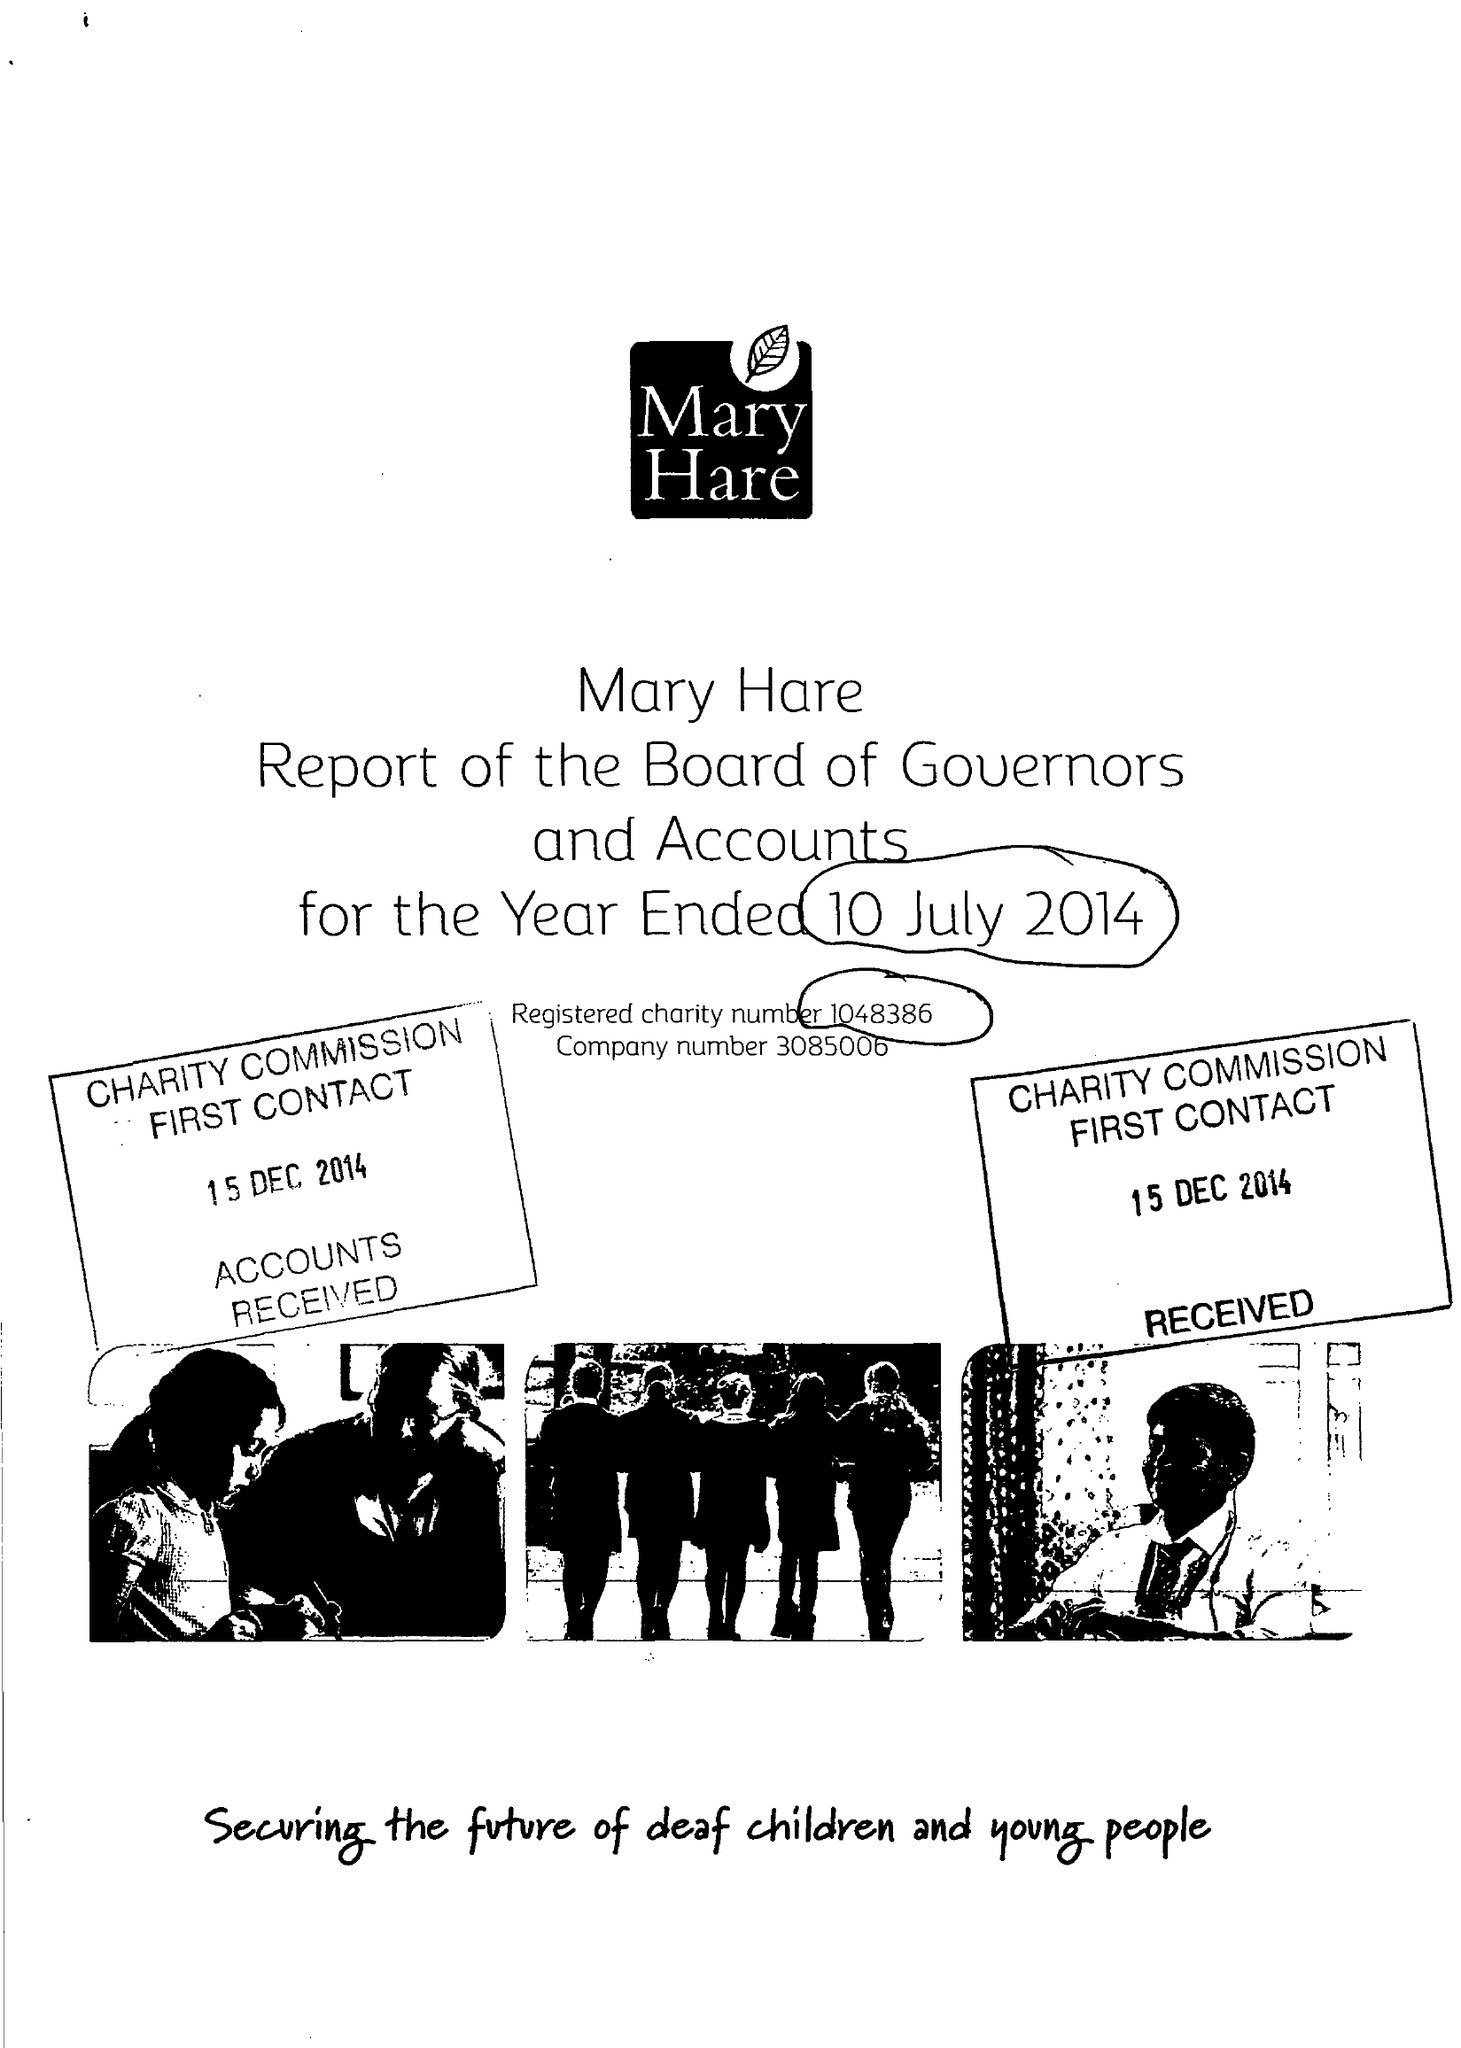What is the value for the charity_number?
Answer the question using a single word or phrase. 1048386 